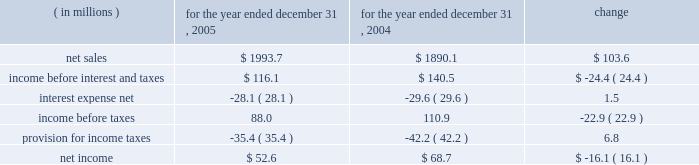Item 7 .
Management 2019s discussion and analysis of financial condition and results of operations the following discussion of historical results of operations and financial condition should be read in conjunction with the audited financial statements and the notes thereto which appear elsewhere in this report .
Overview on april 12 , 1999 , pca acquired the containerboard and corrugated products business of pactiv corporation ( the 201cgroup 201d ) , formerly known as tenneco packaging inc. , a wholly owned subsidiary of tenneco , inc .
The group operated prior to april 12 , 1999 as a division of pactiv , and not as a separate , stand-alone entity .
From its formation in january 1999 and through the closing of the acquisition on april 12 , 1999 , pca did not have any significant operations .
The april 12 , 1999 acquisition was accounted for using historical values for the contributed assets .
Purchase accounting was not applied because , under the applicable accounting guidance , a change of control was deemed not to have occurred as a result of the participating veto rights held by pactiv after the closing of the transactions under the terms of the stockholders agreement entered into in connection with the transactions .
Results of operations year ended december 31 , 2005 compared to year ended december 31 , 2004 the historical results of operations of pca for the years ended december , 31 2005 and 2004 are set forth the below : for the year ended december 31 , ( in millions ) 2005 2004 change .
Net sales net sales increased by $ 103.6 million , or 5.5% ( 5.5 % ) , for the year ended december 31 , 2005 from the year ended december 31 , 2004 .
Net sales increased primarily due to increased sales prices and volumes of corrugated products compared to 2004 .
Total corrugated products volume sold increased 4.2% ( 4.2 % ) to 31.2 billion square feet in 2005 compared to 29.9 billion square feet in 2004 .
On a comparable shipment-per-workday basis , corrugated products sales volume increased 4.6% ( 4.6 % ) in 2005 from 2004 .
Excluding pca 2019s acquisition of midland container in april 2005 , corrugated products volume was 3.0% ( 3.0 % ) higher in 2005 than 2004 and up 3.4% ( 3.4 % ) compared to 2004 on a shipment-per-workday basis .
Shipments-per-workday is calculated by dividing our total corrugated products volume during the year by the number of workdays within the year .
The larger percentage increase was due to the fact that 2005 had one less workday ( 250 days ) , those days not falling on a weekend or holiday , than 2004 ( 251 days ) .
Containerboard sales volume to external domestic and export customers decreased 12.2% ( 12.2 % ) to 417000 tons for the year ended december 31 , 2005 from 475000 tons in 2004. .
What was total interest expense in millions in 2005 and 2004? 
Computations: (28.1 + 29.6)
Answer: 57.7. Item 7 .
Management 2019s discussion and analysis of financial condition and results of operations the following discussion of historical results of operations and financial condition should be read in conjunction with the audited financial statements and the notes thereto which appear elsewhere in this report .
Overview on april 12 , 1999 , pca acquired the containerboard and corrugated products business of pactiv corporation ( the 201cgroup 201d ) , formerly known as tenneco packaging inc. , a wholly owned subsidiary of tenneco , inc .
The group operated prior to april 12 , 1999 as a division of pactiv , and not as a separate , stand-alone entity .
From its formation in january 1999 and through the closing of the acquisition on april 12 , 1999 , pca did not have any significant operations .
The april 12 , 1999 acquisition was accounted for using historical values for the contributed assets .
Purchase accounting was not applied because , under the applicable accounting guidance , a change of control was deemed not to have occurred as a result of the participating veto rights held by pactiv after the closing of the transactions under the terms of the stockholders agreement entered into in connection with the transactions .
Results of operations year ended december 31 , 2005 compared to year ended december 31 , 2004 the historical results of operations of pca for the years ended december , 31 2005 and 2004 are set forth the below : for the year ended december 31 , ( in millions ) 2005 2004 change .
Net sales net sales increased by $ 103.6 million , or 5.5% ( 5.5 % ) , for the year ended december 31 , 2005 from the year ended december 31 , 2004 .
Net sales increased primarily due to increased sales prices and volumes of corrugated products compared to 2004 .
Total corrugated products volume sold increased 4.2% ( 4.2 % ) to 31.2 billion square feet in 2005 compared to 29.9 billion square feet in 2004 .
On a comparable shipment-per-workday basis , corrugated products sales volume increased 4.6% ( 4.6 % ) in 2005 from 2004 .
Excluding pca 2019s acquisition of midland container in april 2005 , corrugated products volume was 3.0% ( 3.0 % ) higher in 2005 than 2004 and up 3.4% ( 3.4 % ) compared to 2004 on a shipment-per-workday basis .
Shipments-per-workday is calculated by dividing our total corrugated products volume during the year by the number of workdays within the year .
The larger percentage increase was due to the fact that 2005 had one less workday ( 250 days ) , those days not falling on a weekend or holiday , than 2004 ( 251 days ) .
Containerboard sales volume to external domestic and export customers decreased 12.2% ( 12.2 % ) to 417000 tons for the year ended december 31 , 2005 from 475000 tons in 2004. .
What was the effective tax rate for pca in 2005? 
Computations: (35.4 / 88.0)
Answer: 0.40227. Item 7 .
Management 2019s discussion and analysis of financial condition and results of operations the following discussion of historical results of operations and financial condition should be read in conjunction with the audited financial statements and the notes thereto which appear elsewhere in this report .
Overview on april 12 , 1999 , pca acquired the containerboard and corrugated products business of pactiv corporation ( the 201cgroup 201d ) , formerly known as tenneco packaging inc. , a wholly owned subsidiary of tenneco , inc .
The group operated prior to april 12 , 1999 as a division of pactiv , and not as a separate , stand-alone entity .
From its formation in january 1999 and through the closing of the acquisition on april 12 , 1999 , pca did not have any significant operations .
The april 12 , 1999 acquisition was accounted for using historical values for the contributed assets .
Purchase accounting was not applied because , under the applicable accounting guidance , a change of control was deemed not to have occurred as a result of the participating veto rights held by pactiv after the closing of the transactions under the terms of the stockholders agreement entered into in connection with the transactions .
Results of operations year ended december 31 , 2005 compared to year ended december 31 , 2004 the historical results of operations of pca for the years ended december , 31 2005 and 2004 are set forth the below : for the year ended december 31 , ( in millions ) 2005 2004 change .
Net sales net sales increased by $ 103.6 million , or 5.5% ( 5.5 % ) , for the year ended december 31 , 2005 from the year ended december 31 , 2004 .
Net sales increased primarily due to increased sales prices and volumes of corrugated products compared to 2004 .
Total corrugated products volume sold increased 4.2% ( 4.2 % ) to 31.2 billion square feet in 2005 compared to 29.9 billion square feet in 2004 .
On a comparable shipment-per-workday basis , corrugated products sales volume increased 4.6% ( 4.6 % ) in 2005 from 2004 .
Excluding pca 2019s acquisition of midland container in april 2005 , corrugated products volume was 3.0% ( 3.0 % ) higher in 2005 than 2004 and up 3.4% ( 3.4 % ) compared to 2004 on a shipment-per-workday basis .
Shipments-per-workday is calculated by dividing our total corrugated products volume during the year by the number of workdays within the year .
The larger percentage increase was due to the fact that 2005 had one less workday ( 250 days ) , those days not falling on a weekend or holiday , than 2004 ( 251 days ) .
Containerboard sales volume to external domestic and export customers decreased 12.2% ( 12.2 % ) to 417000 tons for the year ended december 31 , 2005 from 475000 tons in 2004. .
In millions , what was the total income before taxes in 2005 and 2004? 
Computations: (88.0 + 110.9)
Answer: 198.9. 